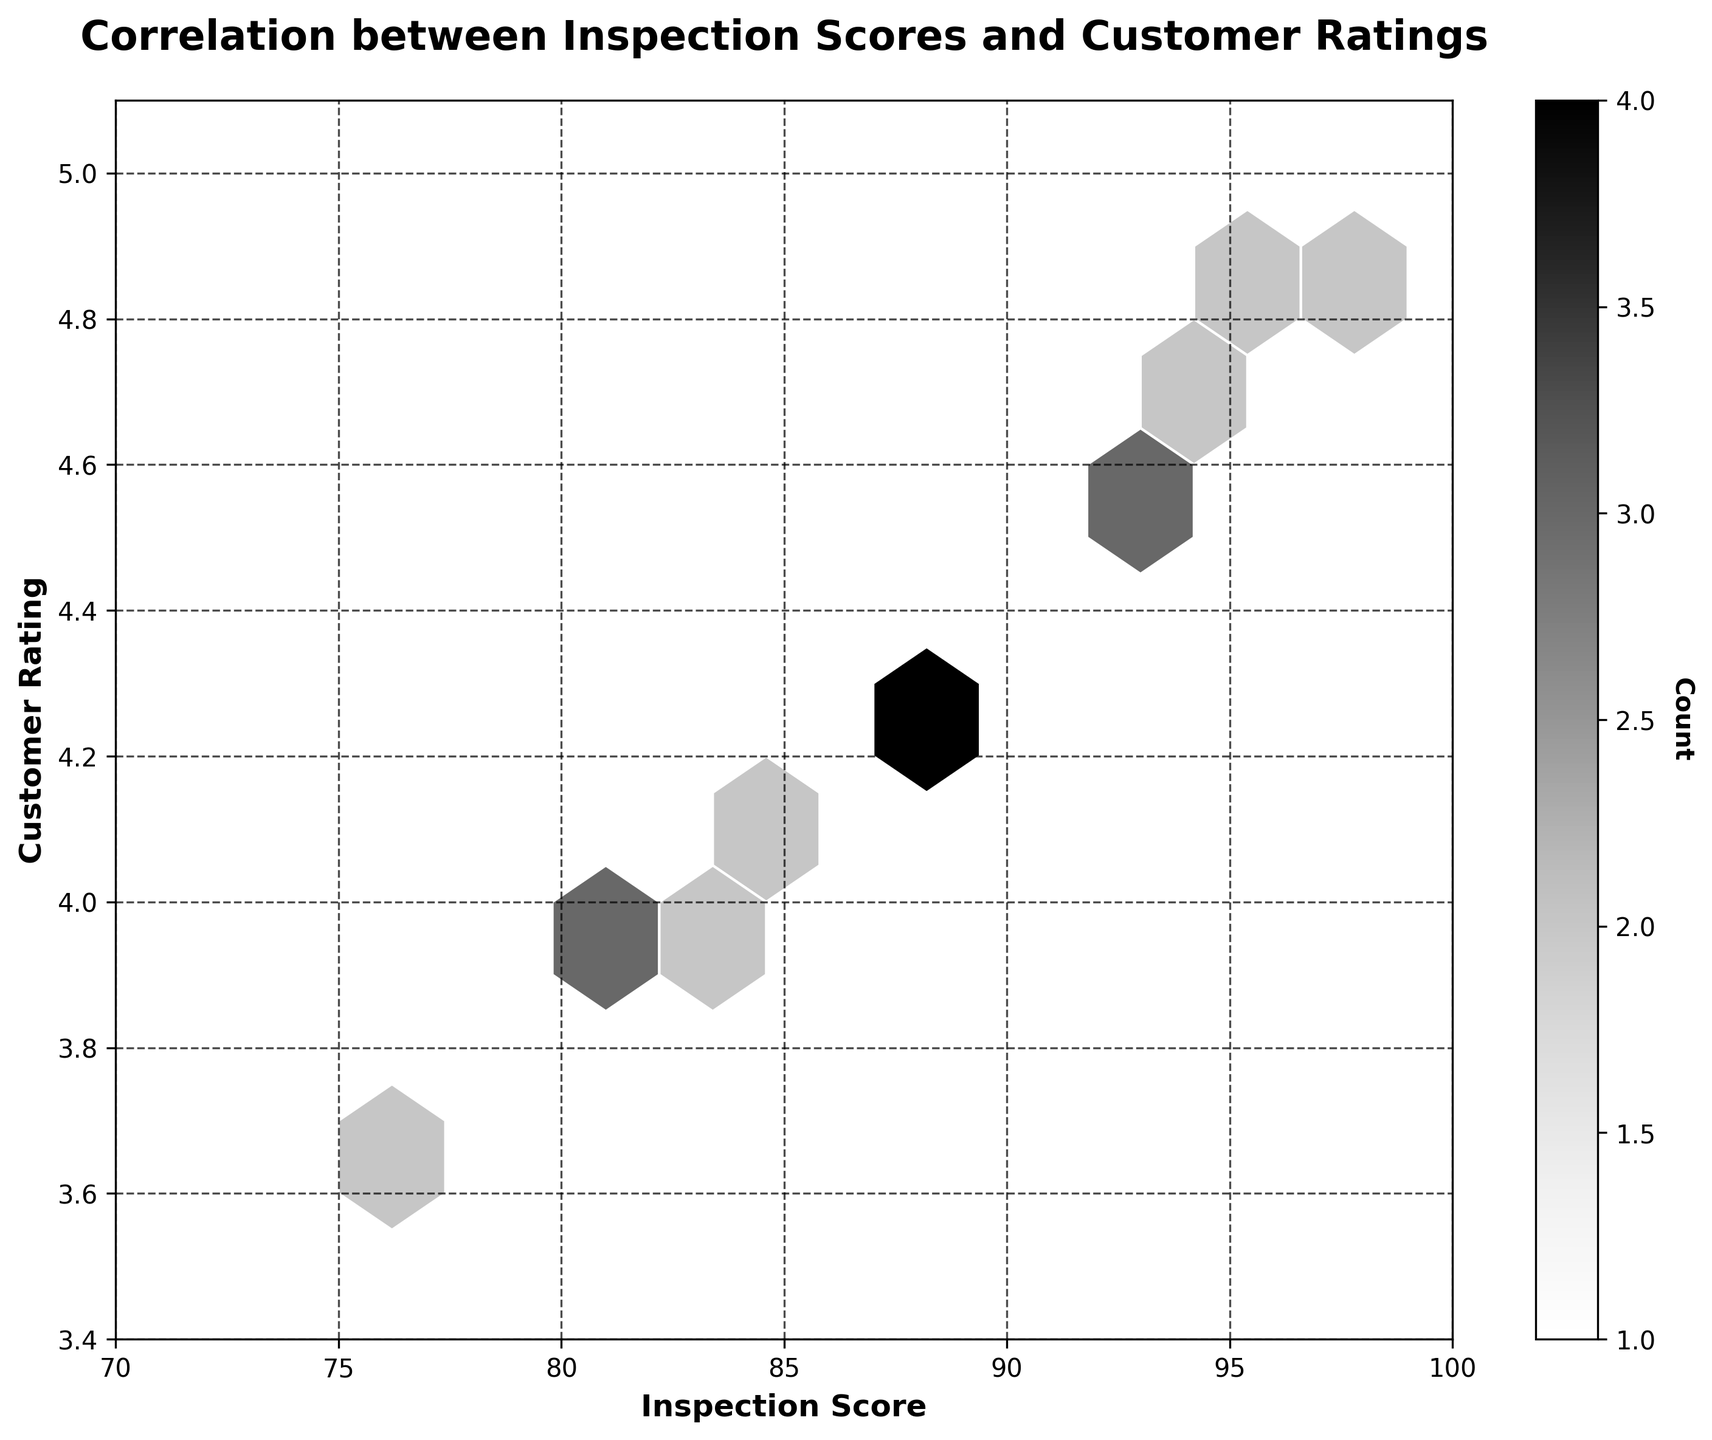What is the title of the plot? The title of the plot is usually displayed at the top and provides a summary of what the plot depicts. Look at the top of the figure to find it.
Answer: Correlation between Inspection Scores and Customer Ratings What are the ranges for the inspection scores and customer ratings on the axes? The range of values is given at the ends of the x and y axes. For inspection scores, the range is shown on the x-axis (horizontal), and for customer ratings, the range is shown on the y-axis (vertical).
Answer: 70 to 100 and 3.4 to 5.1 What does the color intensity in the hexbin plot represent? In a hexbin plot, the color represents the number of data points falling into each hexagonal bin. The color bar on the side of the plot indicates this information. Darker colors mean more data points in that bin.
Answer: Count of data points How many bins contain the highest counts, and what does this imply about the data? The color bar can help determine which color represents the highest count of data points and then look for how many hexagons have this color. This implies the density of data points in those score-rating bins is highest.
Answer: There is usually one bin with the highest count, implying a cluster Do higher inspection scores correlate with higher customer ratings? To determine correlation, observe the trend in the hexagons from left to right and bottom to top. If hexagons are more concentrated from lower-left to upper-right, it indicates positive correlation.
Answer: Yes, positively correlated Where on the plot is the highest density of inspection and rating scores? The highest density can be identified where the hexagons have the darkest shade (based on the color bar legend). Check which inspection scores and customer ratings fall in this bin.
Answer: Between inspection scores of 90-100 and customer ratings of 4.4-5.0 What is the color of hexagons representing single data points, and what does it indicate? The color bar can help find the color associated with the count of '1'. Hexagons with this color indicate regions where only one data point falls in that bin.
Answer: Lightest shade, indicating sparse data points From the color bar, what is the maximum count of data points in one bin, and what does it suggest? Look at the darkest color on the color bar and read the count corresponding to that color. This tells the maximum number of data points that fell into a single bin.
Answer: The maximum bin count varies but suggests clustering Which regions of the hexbin plot show the least customer ratings? Regions with the lightest hexagons or the areas outside the shaded bins typically represent fewer or no customer ratings, displayed at the low end of the color bar.
Answer: Areas with ratings roughly 3.4-4.0 What axis labels are provided on the plot, and why are they important? Check the labels beside the x-axis and y-axis for what they represent. These labels are important to understand what each axis measures so we can interpret data correctly.
Answer: Inspection Score and Customer Rating 